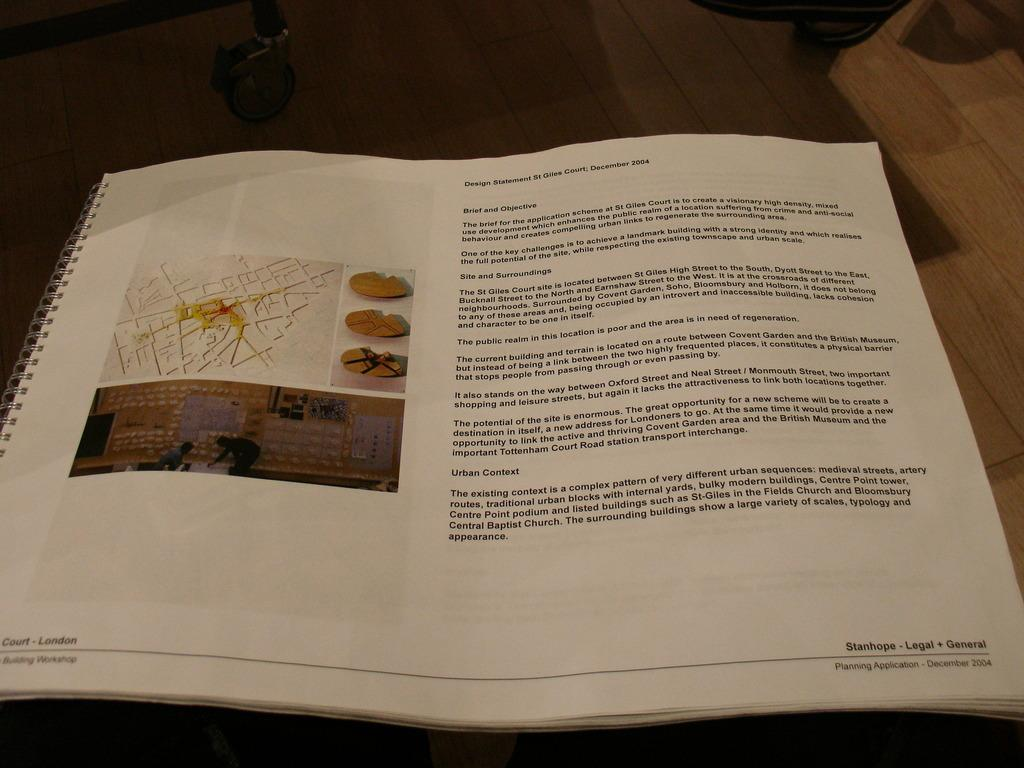Provide a one-sentence caption for the provided image. a book that says 'stanhope-legal + general' on it. 